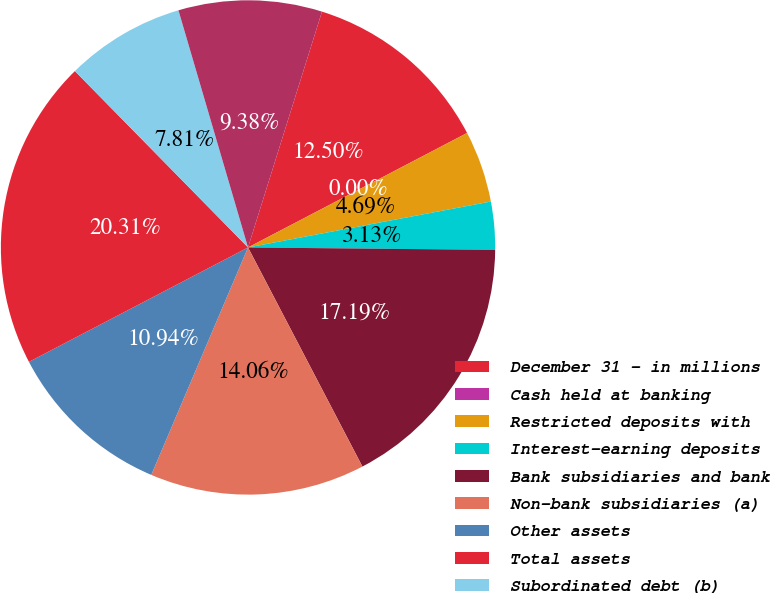Convert chart to OTSL. <chart><loc_0><loc_0><loc_500><loc_500><pie_chart><fcel>December 31 - in millions<fcel>Cash held at banking<fcel>Restricted deposits with<fcel>Interest-earning deposits<fcel>Bank subsidiaries and bank<fcel>Non-bank subsidiaries (a)<fcel>Other assets<fcel>Total assets<fcel>Subordinated debt (b)<fcel>Senior debt (b)<nl><fcel>12.5%<fcel>0.0%<fcel>4.69%<fcel>3.13%<fcel>17.19%<fcel>14.06%<fcel>10.94%<fcel>20.31%<fcel>7.81%<fcel>9.38%<nl></chart> 